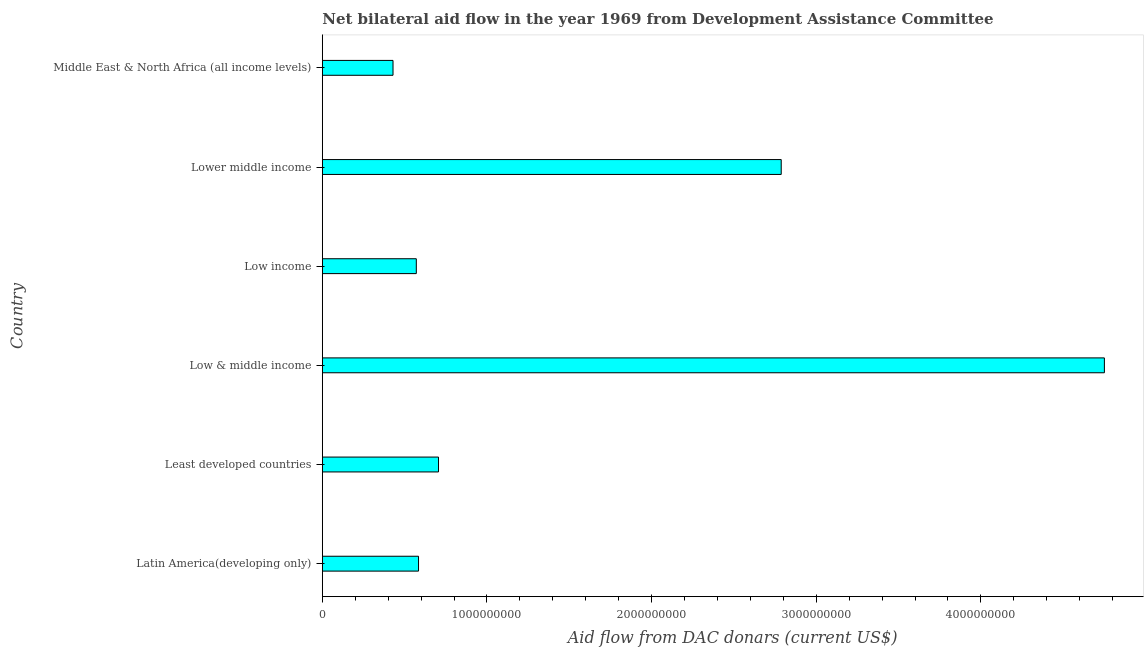Does the graph contain any zero values?
Offer a very short reply. No. What is the title of the graph?
Provide a succinct answer. Net bilateral aid flow in the year 1969 from Development Assistance Committee. What is the label or title of the X-axis?
Your answer should be compact. Aid flow from DAC donars (current US$). What is the label or title of the Y-axis?
Keep it short and to the point. Country. What is the net bilateral aid flows from dac donors in Least developed countries?
Give a very brief answer. 7.06e+08. Across all countries, what is the maximum net bilateral aid flows from dac donors?
Ensure brevity in your answer.  4.75e+09. Across all countries, what is the minimum net bilateral aid flows from dac donors?
Give a very brief answer. 4.29e+08. In which country was the net bilateral aid flows from dac donors maximum?
Keep it short and to the point. Low & middle income. In which country was the net bilateral aid flows from dac donors minimum?
Provide a short and direct response. Middle East & North Africa (all income levels). What is the sum of the net bilateral aid flows from dac donors?
Provide a short and direct response. 9.83e+09. What is the difference between the net bilateral aid flows from dac donors in Low & middle income and Lower middle income?
Provide a succinct answer. 1.96e+09. What is the average net bilateral aid flows from dac donors per country?
Offer a terse response. 1.64e+09. What is the median net bilateral aid flows from dac donors?
Your answer should be compact. 6.45e+08. In how many countries, is the net bilateral aid flows from dac donors greater than 3600000000 US$?
Keep it short and to the point. 1. What is the ratio of the net bilateral aid flows from dac donors in Low income to that in Middle East & North Africa (all income levels)?
Keep it short and to the point. 1.33. Is the net bilateral aid flows from dac donors in Latin America(developing only) less than that in Lower middle income?
Provide a short and direct response. Yes. Is the difference between the net bilateral aid flows from dac donors in Least developed countries and Low & middle income greater than the difference between any two countries?
Give a very brief answer. No. What is the difference between the highest and the second highest net bilateral aid flows from dac donors?
Make the answer very short. 1.96e+09. What is the difference between the highest and the lowest net bilateral aid flows from dac donors?
Your answer should be compact. 4.32e+09. How many countries are there in the graph?
Offer a very short reply. 6. What is the difference between two consecutive major ticks on the X-axis?
Provide a succinct answer. 1.00e+09. Are the values on the major ticks of X-axis written in scientific E-notation?
Your answer should be compact. No. What is the Aid flow from DAC donars (current US$) in Latin America(developing only)?
Keep it short and to the point. 5.84e+08. What is the Aid flow from DAC donars (current US$) in Least developed countries?
Provide a succinct answer. 7.06e+08. What is the Aid flow from DAC donars (current US$) of Low & middle income?
Your response must be concise. 4.75e+09. What is the Aid flow from DAC donars (current US$) in Low income?
Provide a short and direct response. 5.71e+08. What is the Aid flow from DAC donars (current US$) of Lower middle income?
Your answer should be very brief. 2.79e+09. What is the Aid flow from DAC donars (current US$) in Middle East & North Africa (all income levels)?
Offer a terse response. 4.29e+08. What is the difference between the Aid flow from DAC donars (current US$) in Latin America(developing only) and Least developed countries?
Provide a succinct answer. -1.21e+08. What is the difference between the Aid flow from DAC donars (current US$) in Latin America(developing only) and Low & middle income?
Your answer should be very brief. -4.17e+09. What is the difference between the Aid flow from DAC donars (current US$) in Latin America(developing only) and Low income?
Your answer should be compact. 1.35e+07. What is the difference between the Aid flow from DAC donars (current US$) in Latin America(developing only) and Lower middle income?
Offer a very short reply. -2.20e+09. What is the difference between the Aid flow from DAC donars (current US$) in Latin America(developing only) and Middle East & North Africa (all income levels)?
Your response must be concise. 1.55e+08. What is the difference between the Aid flow from DAC donars (current US$) in Least developed countries and Low & middle income?
Make the answer very short. -4.04e+09. What is the difference between the Aid flow from DAC donars (current US$) in Least developed countries and Low income?
Ensure brevity in your answer.  1.35e+08. What is the difference between the Aid flow from DAC donars (current US$) in Least developed countries and Lower middle income?
Offer a terse response. -2.08e+09. What is the difference between the Aid flow from DAC donars (current US$) in Least developed countries and Middle East & North Africa (all income levels)?
Your answer should be very brief. 2.76e+08. What is the difference between the Aid flow from DAC donars (current US$) in Low & middle income and Low income?
Offer a terse response. 4.18e+09. What is the difference between the Aid flow from DAC donars (current US$) in Low & middle income and Lower middle income?
Keep it short and to the point. 1.96e+09. What is the difference between the Aid flow from DAC donars (current US$) in Low & middle income and Middle East & North Africa (all income levels)?
Provide a succinct answer. 4.32e+09. What is the difference between the Aid flow from DAC donars (current US$) in Low income and Lower middle income?
Keep it short and to the point. -2.22e+09. What is the difference between the Aid flow from DAC donars (current US$) in Low income and Middle East & North Africa (all income levels)?
Keep it short and to the point. 1.42e+08. What is the difference between the Aid flow from DAC donars (current US$) in Lower middle income and Middle East & North Africa (all income levels)?
Your response must be concise. 2.36e+09. What is the ratio of the Aid flow from DAC donars (current US$) in Latin America(developing only) to that in Least developed countries?
Keep it short and to the point. 0.83. What is the ratio of the Aid flow from DAC donars (current US$) in Latin America(developing only) to that in Low & middle income?
Provide a succinct answer. 0.12. What is the ratio of the Aid flow from DAC donars (current US$) in Latin America(developing only) to that in Lower middle income?
Your answer should be very brief. 0.21. What is the ratio of the Aid flow from DAC donars (current US$) in Latin America(developing only) to that in Middle East & North Africa (all income levels)?
Provide a short and direct response. 1.36. What is the ratio of the Aid flow from DAC donars (current US$) in Least developed countries to that in Low & middle income?
Make the answer very short. 0.15. What is the ratio of the Aid flow from DAC donars (current US$) in Least developed countries to that in Low income?
Your answer should be very brief. 1.24. What is the ratio of the Aid flow from DAC donars (current US$) in Least developed countries to that in Lower middle income?
Your answer should be compact. 0.25. What is the ratio of the Aid flow from DAC donars (current US$) in Least developed countries to that in Middle East & North Africa (all income levels)?
Offer a very short reply. 1.64. What is the ratio of the Aid flow from DAC donars (current US$) in Low & middle income to that in Low income?
Ensure brevity in your answer.  8.32. What is the ratio of the Aid flow from DAC donars (current US$) in Low & middle income to that in Lower middle income?
Your answer should be compact. 1.7. What is the ratio of the Aid flow from DAC donars (current US$) in Low & middle income to that in Middle East & North Africa (all income levels)?
Your response must be concise. 11.06. What is the ratio of the Aid flow from DAC donars (current US$) in Low income to that in Lower middle income?
Ensure brevity in your answer.  0.2. What is the ratio of the Aid flow from DAC donars (current US$) in Low income to that in Middle East & North Africa (all income levels)?
Your answer should be compact. 1.33. What is the ratio of the Aid flow from DAC donars (current US$) in Lower middle income to that in Middle East & North Africa (all income levels)?
Make the answer very short. 6.49. 